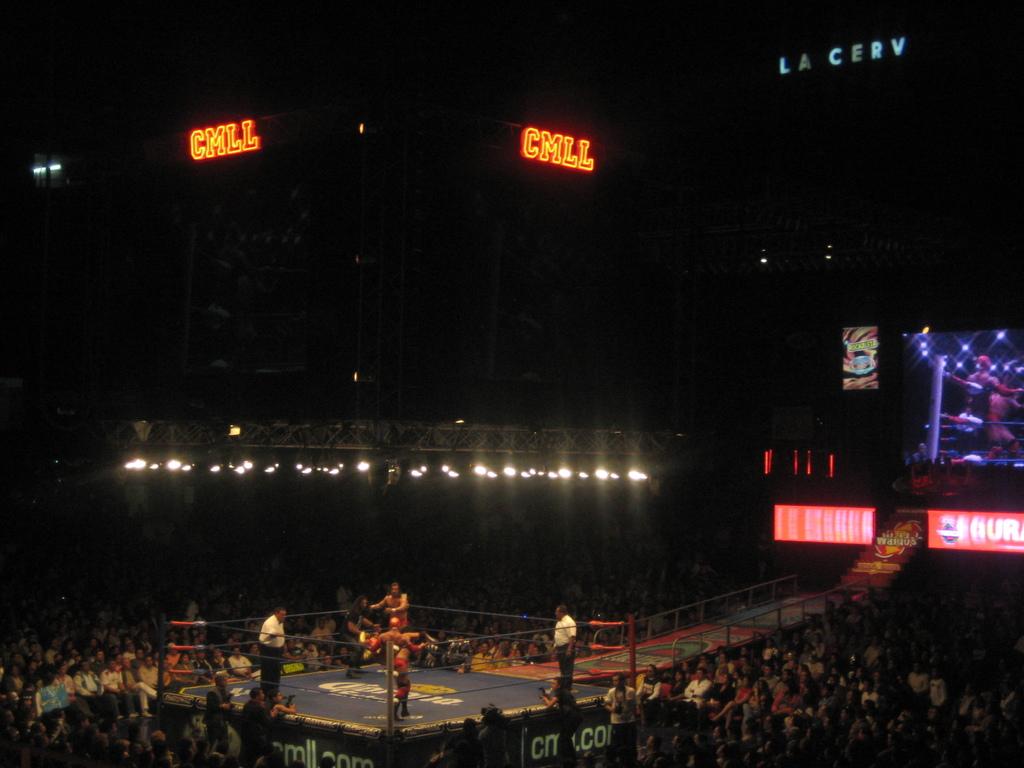Is this a home?
Provide a succinct answer. No. 